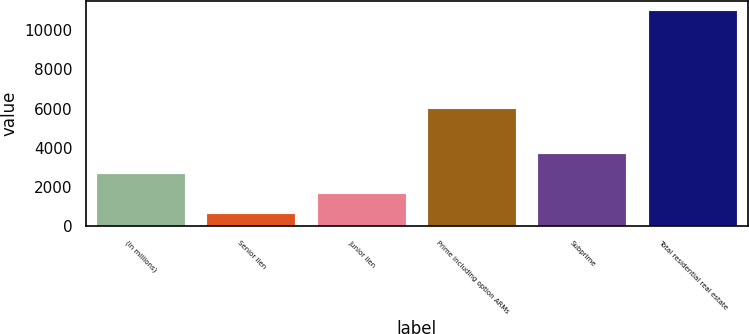<chart> <loc_0><loc_0><loc_500><loc_500><bar_chart><fcel>(in millions)<fcel>Senior lien<fcel>Junior lien<fcel>Prime including option ARMs<fcel>Subprime<fcel>Total residential real estate<nl><fcel>2676.2<fcel>610<fcel>1643.1<fcel>5989<fcel>3709.3<fcel>10941<nl></chart> 